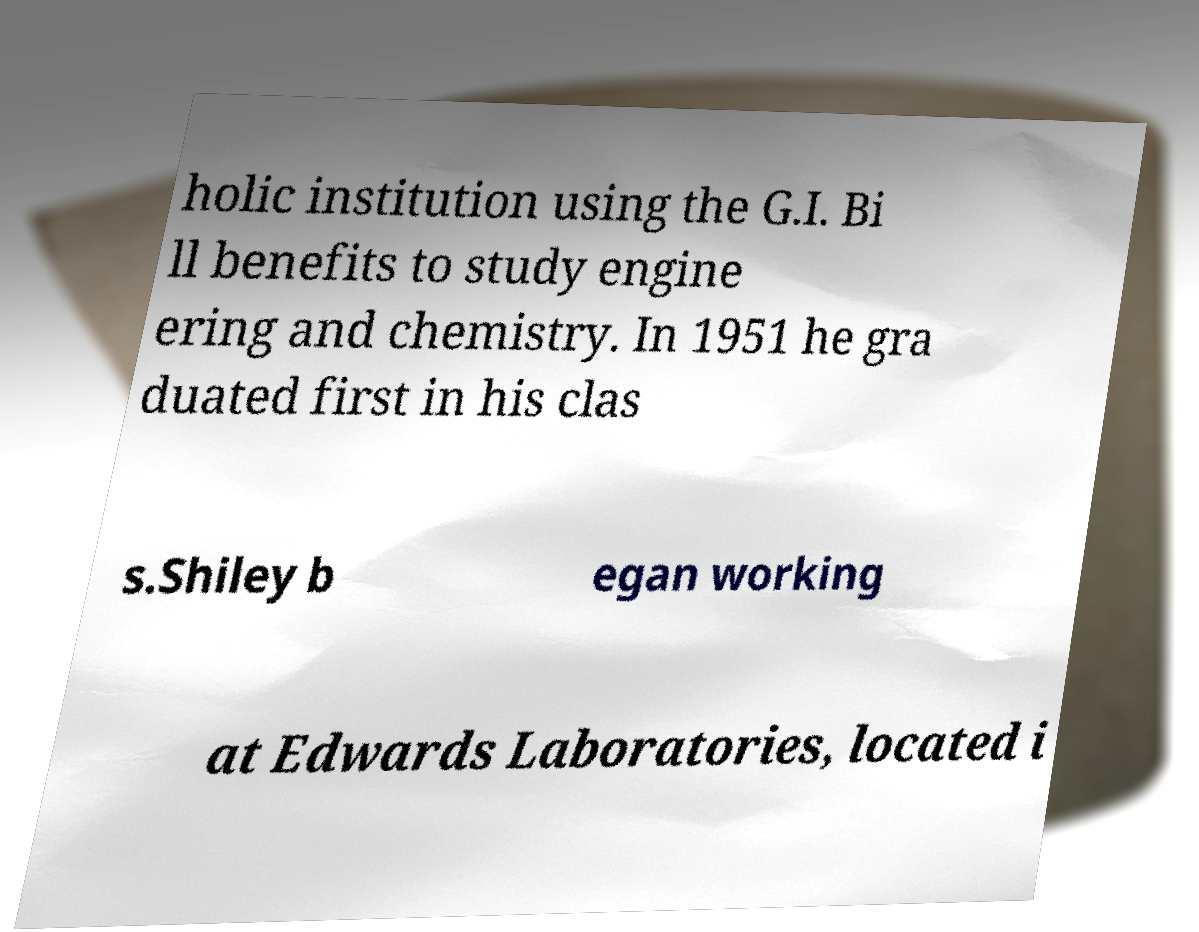What messages or text are displayed in this image? I need them in a readable, typed format. holic institution using the G.I. Bi ll benefits to study engine ering and chemistry. In 1951 he gra duated first in his clas s.Shiley b egan working at Edwards Laboratories, located i 